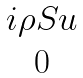Convert formula to latex. <formula><loc_0><loc_0><loc_500><loc_500>\begin{matrix} i \rho S u \\ 0 \end{matrix}</formula> 